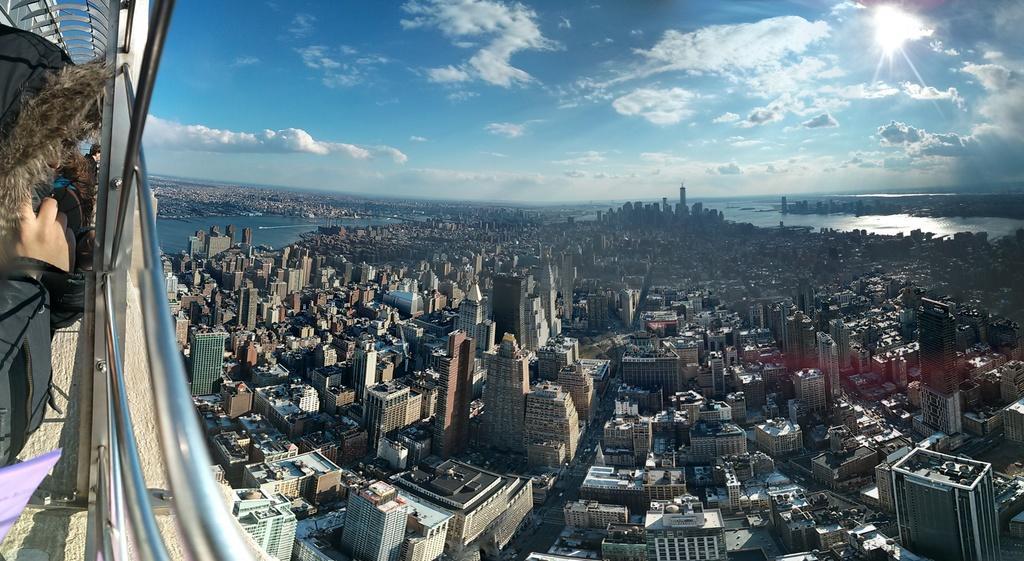Describe this image in one or two sentences. In this picture, we can see a few buildings, water, a person's hand, railing and the sky with clouds. 